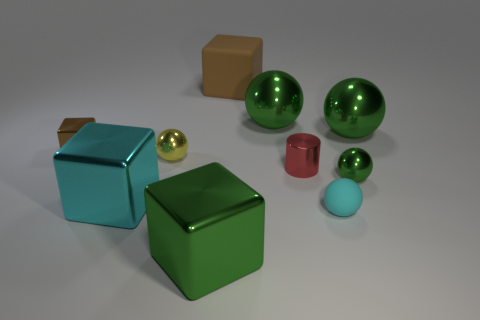Can you describe the texture and color shades of the objects? Certainly! The objects display a variety of textures and shades. The green spheres and cubes exhibit a highly reflective, smooth surface, with deep, vibrant green hues. The smaller objects, like the blue sphere and the red cylinder, have a matte finish with more subdued colors. There's also a brown cube with a smoother texture and a more muted tone. 